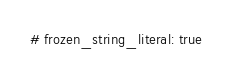Convert code to text. <code><loc_0><loc_0><loc_500><loc_500><_Ruby_># frozen_string_literal: true
</code> 